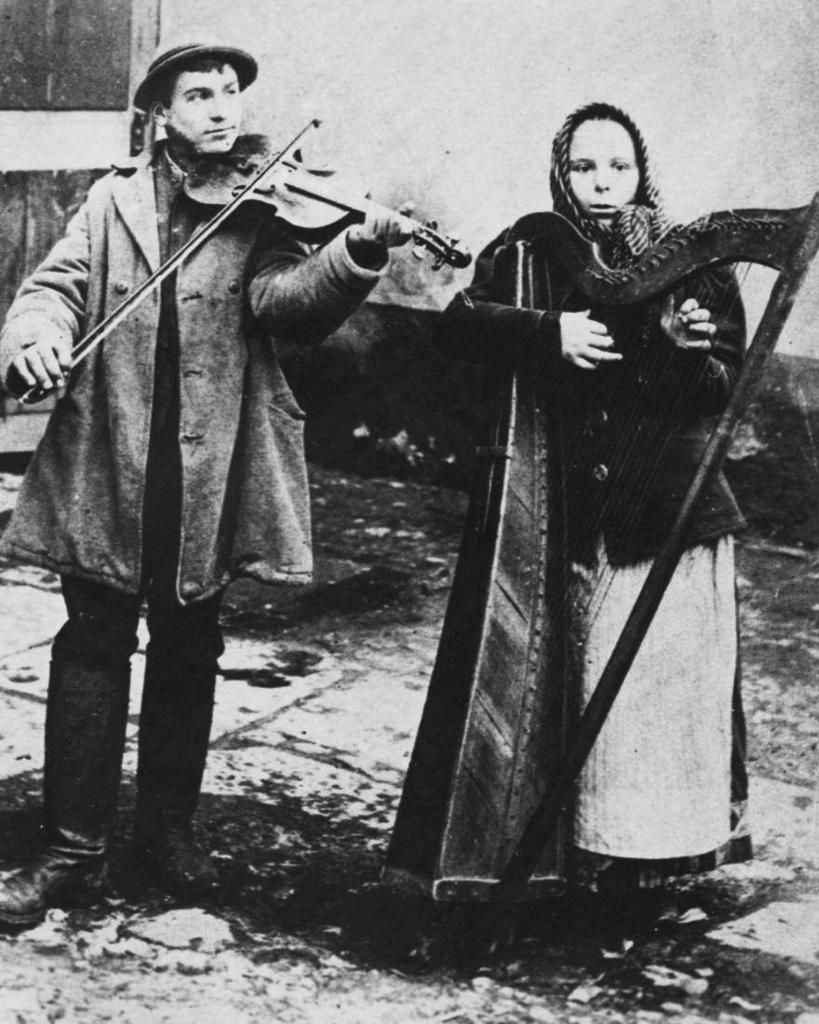How would you summarize this image in a sentence or two? In this image I see a man and a woman standing on the path and both of them are holding an musical instrument. In the background I can see the wall and I can also say this is a black and white picture. 